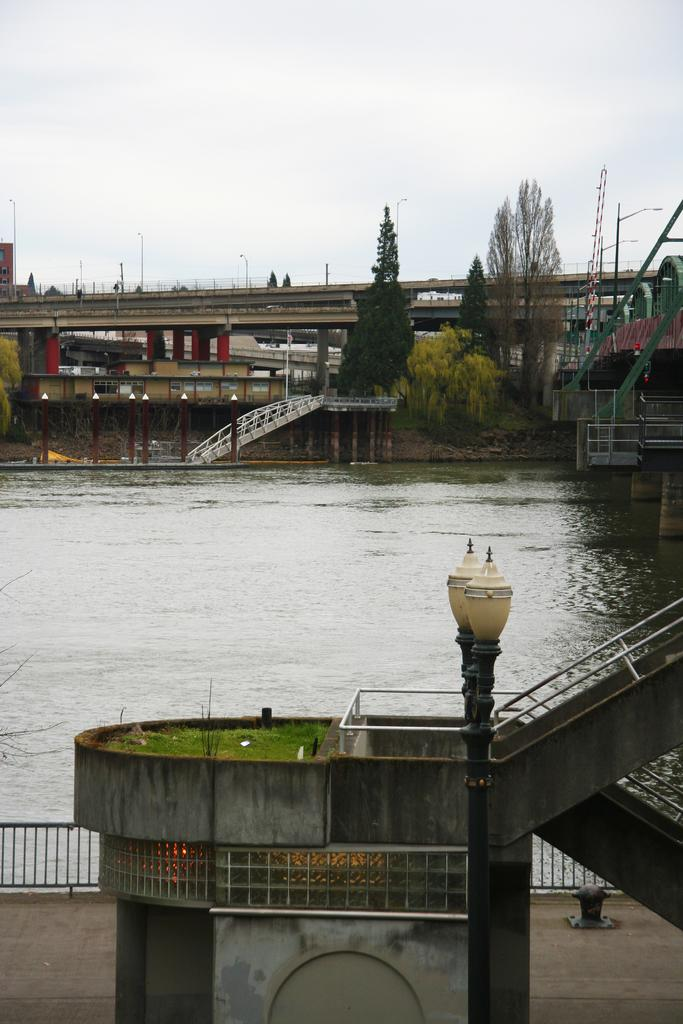What type of structure can be seen in the image? There is a bridge in the image. What material is the grill in the image made of? The grill in the image is made of iron. What type of vegetation is present in the image? There are trees in the image. What type of natural feature can be seen in the image? There are rocks in the image. What type of urban infrastructure is present in the image? There are street poles and street lights in the image. What natural elements can be seen in the image? There is water and sky visible in the image. What atmospheric conditions can be observed in the sky? There are clouds in the sky. Can you see any mist rising from the water in the image? There is no mention of mist in the provided facts, and it cannot be determined from the image. What is the level of disgust expressed by the bridge in the image? The bridge is an inanimate object and cannot express emotions like disgust. 